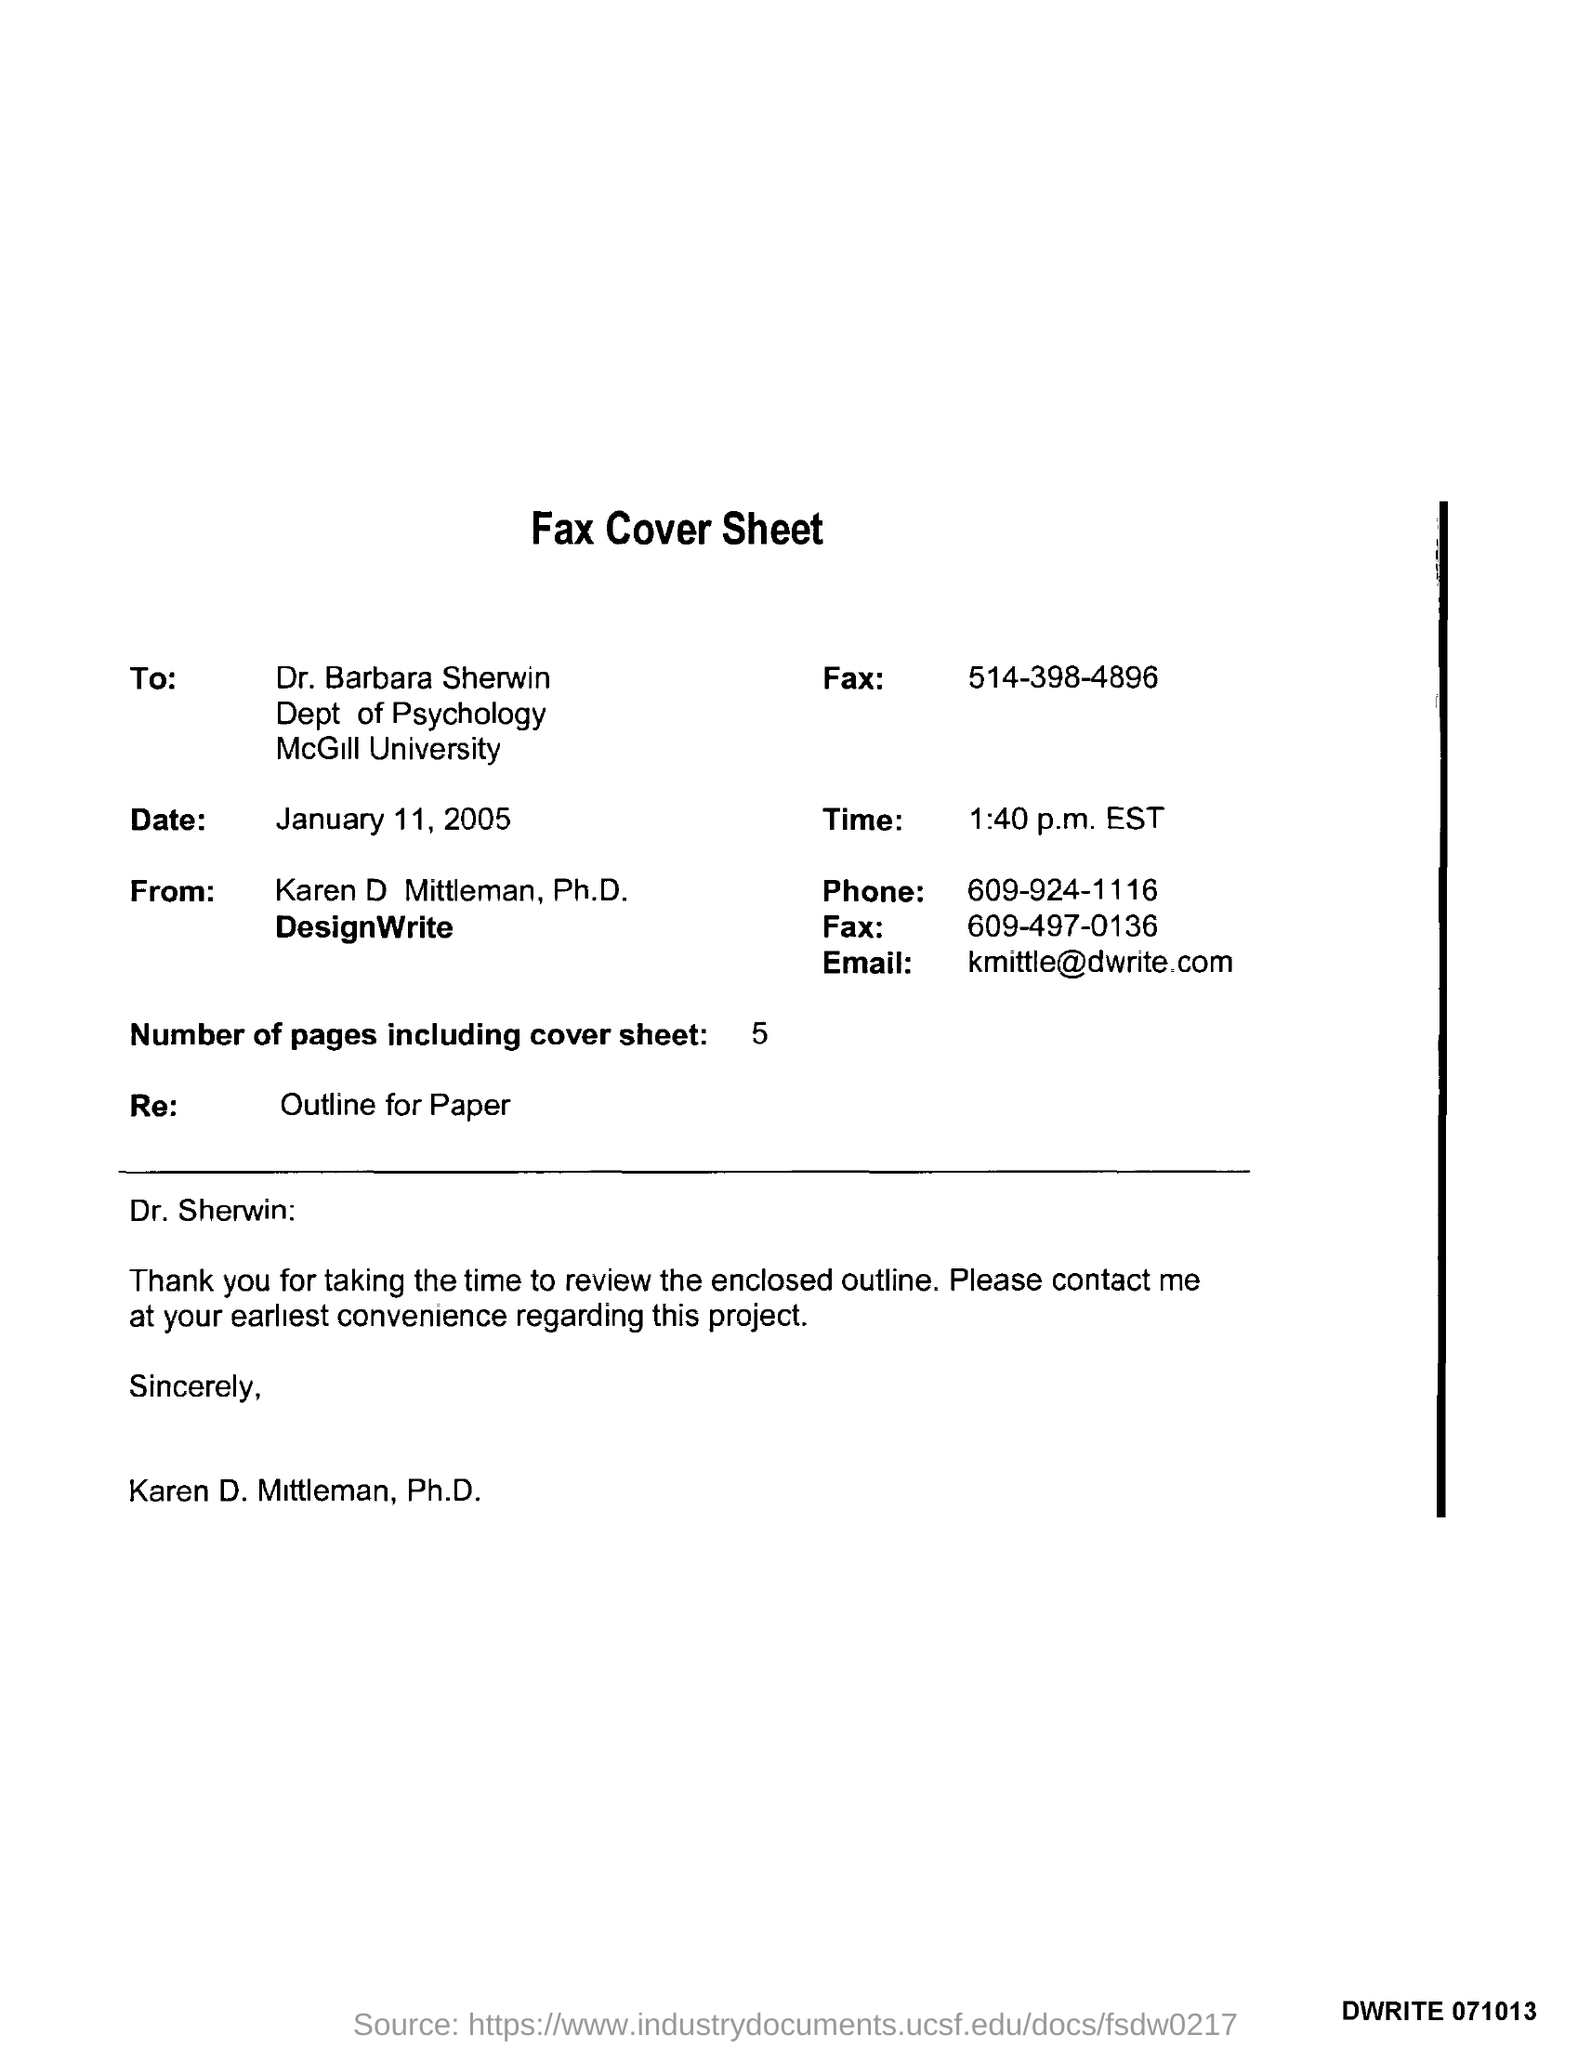Identify some key points in this picture. The date mentioned in the fax cover sheet is January 11, 2005. There are 5 pages in total, including the cover sheet, in the fax. The time mentioned in the fax cover sheet is 1:40 p.m. EST. Karen D. Mittleman, Ph.D. can be contacted at [kmittle@dwrite.com](mailto:kmittle@dwrite.com). Dr. Barbara Sherwin works at McGill University. 